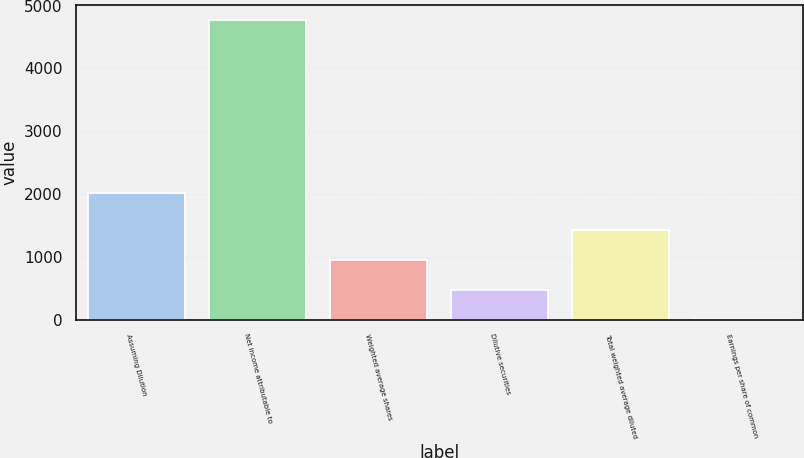Convert chart. <chart><loc_0><loc_0><loc_500><loc_500><bar_chart><fcel>Assuming Dilution<fcel>Net income attributable to<fcel>Weighted average shares<fcel>Dilutive securities<fcel>Total weighted average diluted<fcel>Earnings per share of common<nl><fcel>2015<fcel>4768<fcel>958.44<fcel>482.24<fcel>1434.64<fcel>6.04<nl></chart> 